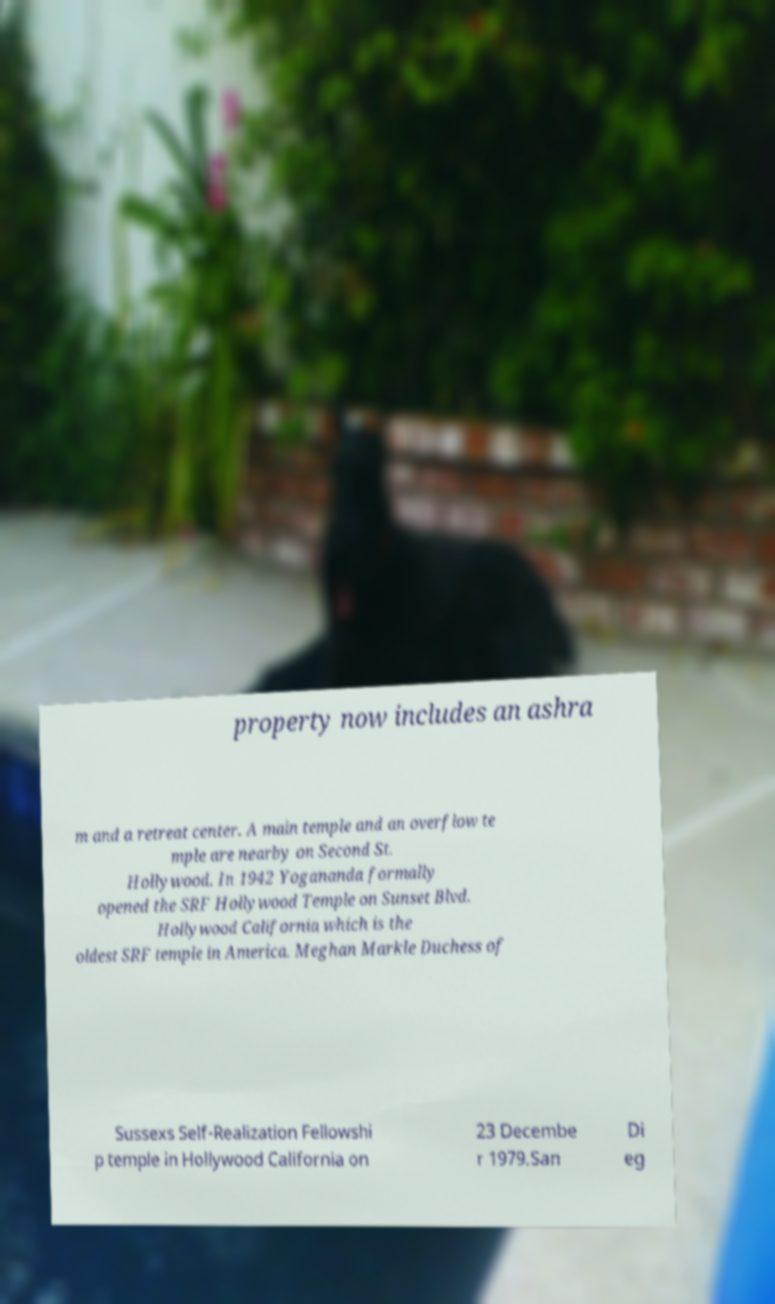Could you extract and type out the text from this image? property now includes an ashra m and a retreat center. A main temple and an overflow te mple are nearby on Second St. Hollywood. In 1942 Yogananda formally opened the SRF Hollywood Temple on Sunset Blvd. Hollywood California which is the oldest SRF temple in America. Meghan Markle Duchess of Sussexs Self-Realization Fellowshi p temple in Hollywood California on 23 Decembe r 1979.San Di eg 